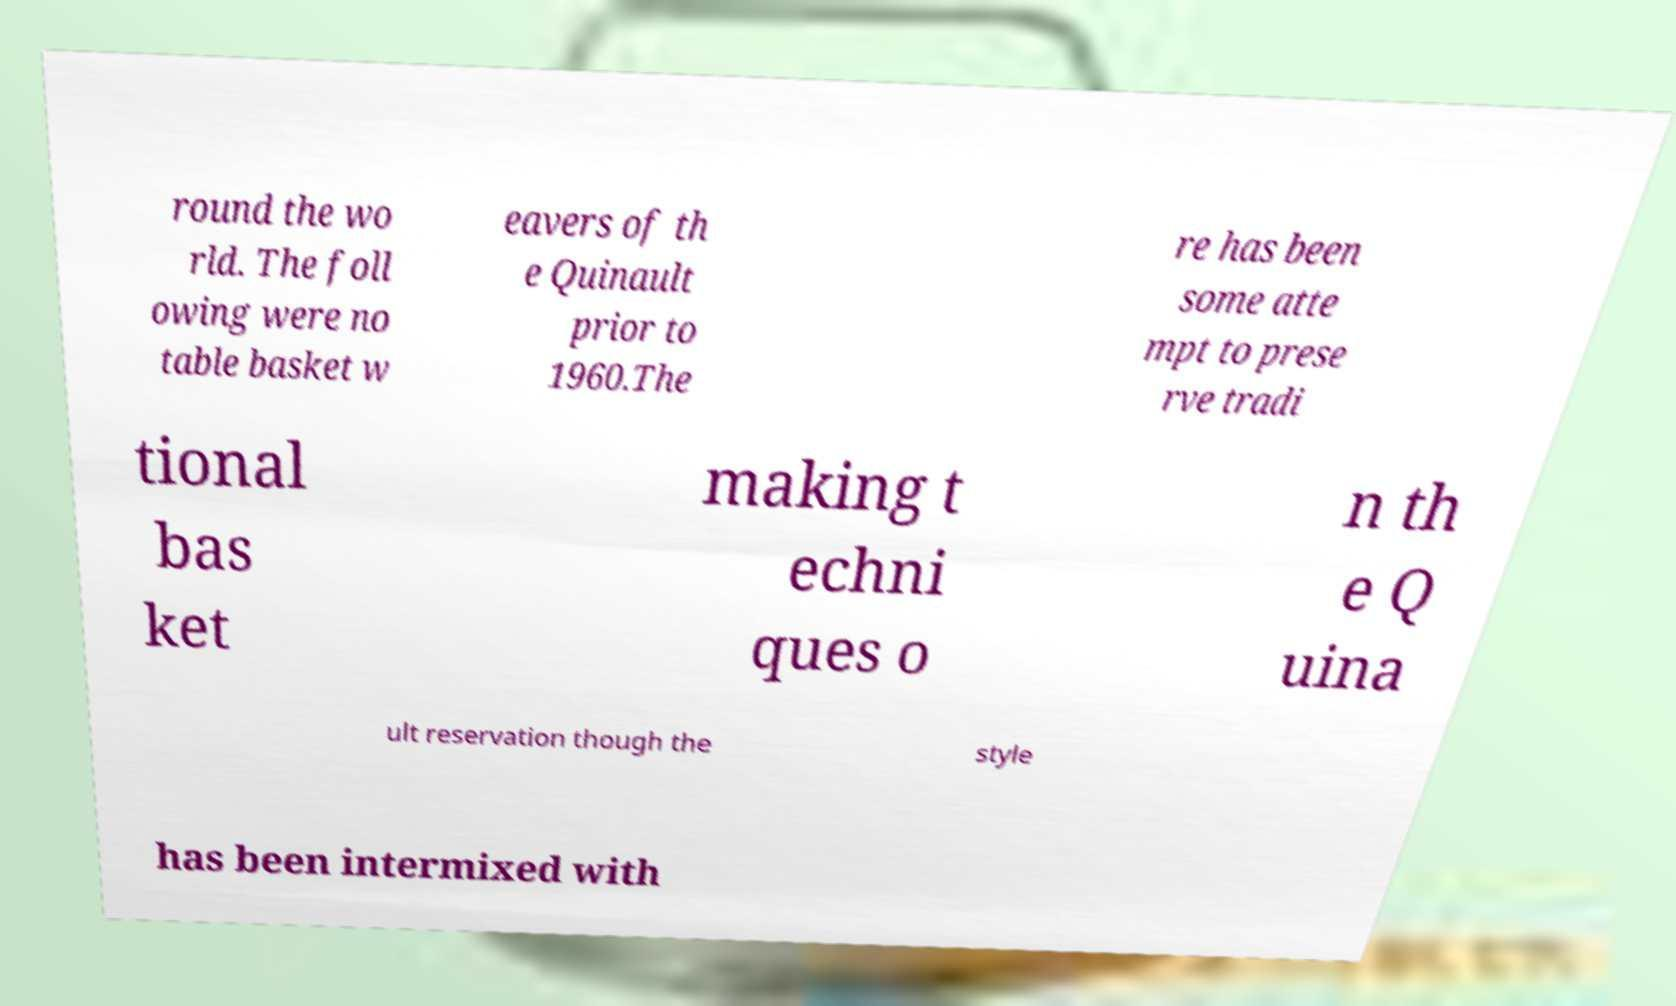What messages or text are displayed in this image? I need them in a readable, typed format. round the wo rld. The foll owing were no table basket w eavers of th e Quinault prior to 1960.The re has been some atte mpt to prese rve tradi tional bas ket making t echni ques o n th e Q uina ult reservation though the style has been intermixed with 